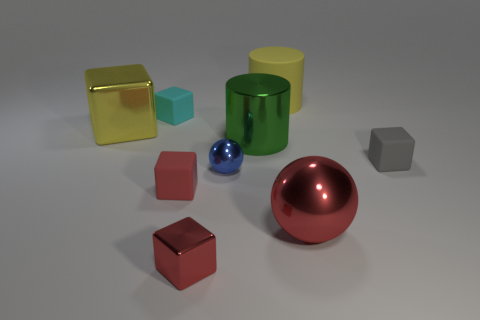There is a small thing that is the same color as the tiny metallic block; what is its shape?
Offer a very short reply. Cube. There is a metallic thing that is the same color as the big rubber object; what is its size?
Ensure brevity in your answer.  Large. Are there more yellow cylinders than shiny cubes?
Keep it short and to the point. No. There is a tiny thing behind the large yellow metallic cube; does it have the same color as the large matte cylinder?
Make the answer very short. No. How many things are either small gray matte blocks in front of the big yellow rubber thing or matte cubes that are in front of the yellow block?
Your answer should be very brief. 2. How many cubes are both right of the tiny cyan rubber block and behind the green thing?
Provide a short and direct response. 0. Is the material of the red sphere the same as the big yellow cube?
Provide a succinct answer. Yes. What is the shape of the small object that is to the left of the tiny red cube on the left side of the small metal thing that is in front of the blue ball?
Provide a short and direct response. Cube. There is a thing that is to the right of the large yellow cylinder and behind the big metallic ball; what is it made of?
Your response must be concise. Rubber. What color is the small sphere in front of the block to the left of the small object that is behind the tiny gray block?
Offer a very short reply. Blue. 